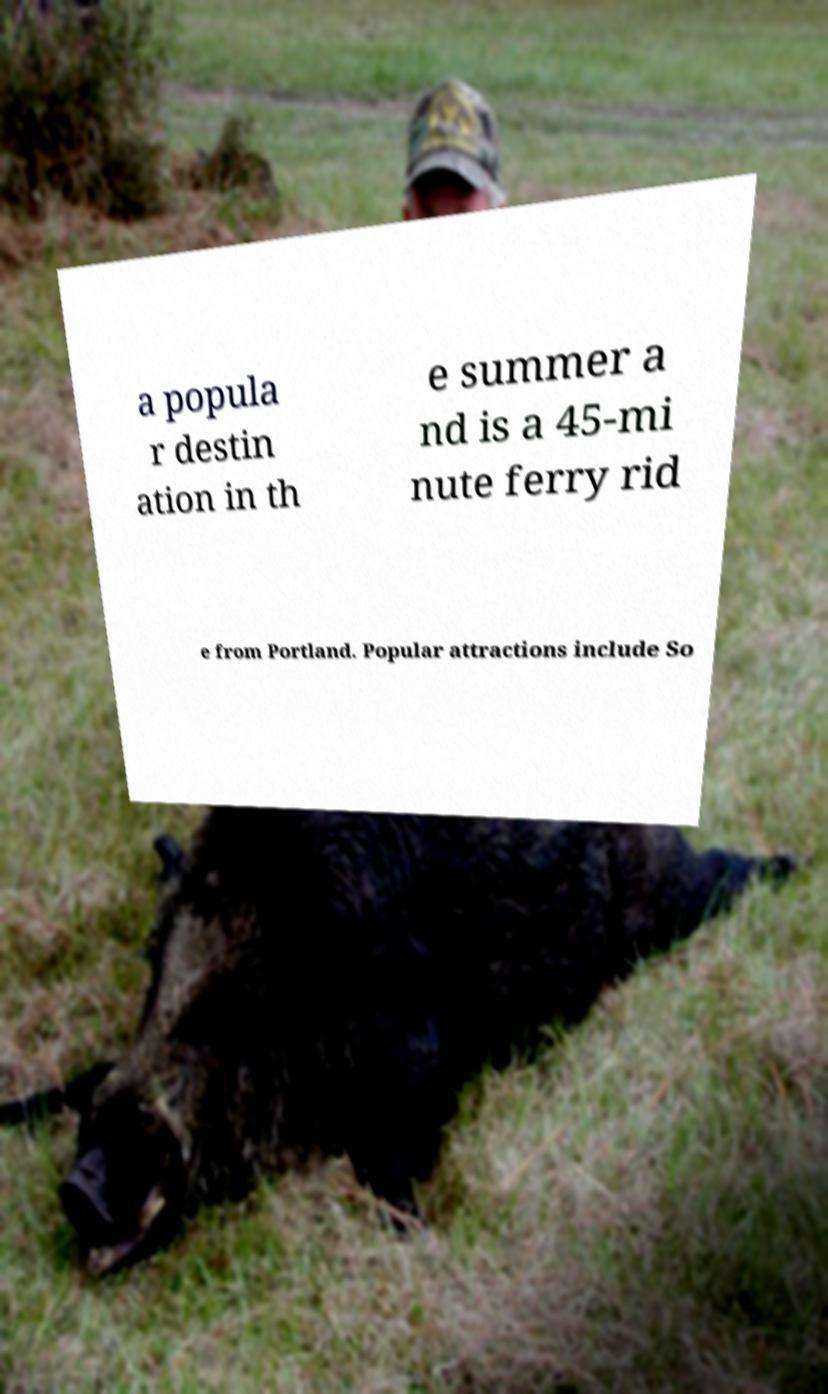I need the written content from this picture converted into text. Can you do that? a popula r destin ation in th e summer a nd is a 45-mi nute ferry rid e from Portland. Popular attractions include So 